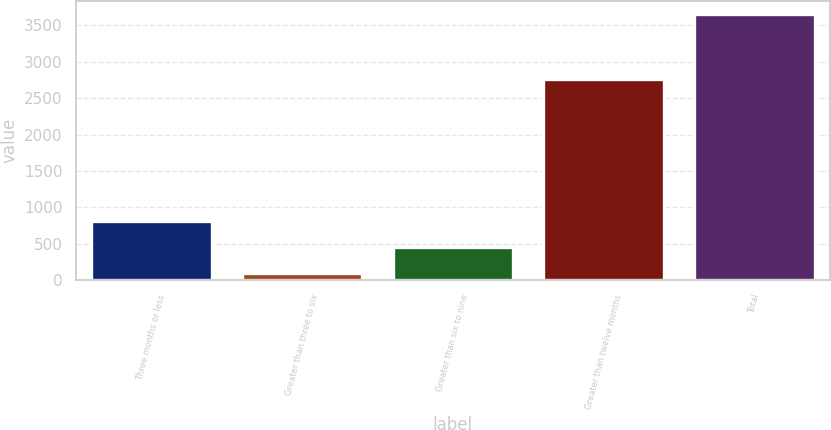Convert chart. <chart><loc_0><loc_0><loc_500><loc_500><bar_chart><fcel>Three months or less<fcel>Greater than three to six<fcel>Greater than six to nine<fcel>Greater than twelve months<fcel>Total<nl><fcel>813.8<fcel>104<fcel>458.9<fcel>2766<fcel>3653<nl></chart> 